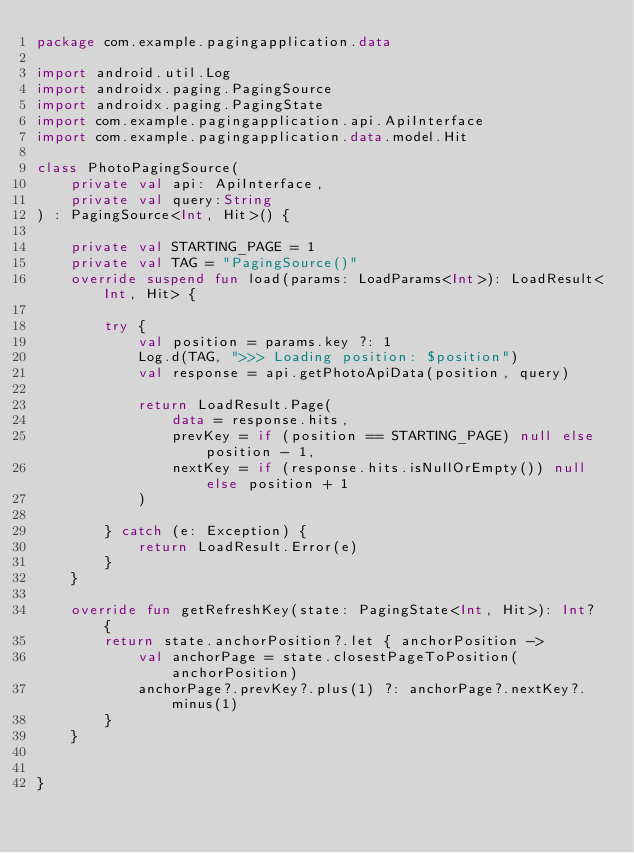Convert code to text. <code><loc_0><loc_0><loc_500><loc_500><_Kotlin_>package com.example.pagingapplication.data

import android.util.Log
import androidx.paging.PagingSource
import androidx.paging.PagingState
import com.example.pagingapplication.api.ApiInterface
import com.example.pagingapplication.data.model.Hit

class PhotoPagingSource(
    private val api: ApiInterface,
    private val query:String
) : PagingSource<Int, Hit>() {

    private val STARTING_PAGE = 1
    private val TAG = "PagingSource()"
    override suspend fun load(params: LoadParams<Int>): LoadResult<Int, Hit> {

        try {
            val position = params.key ?: 1
            Log.d(TAG, ">>> Loading position: $position")
            val response = api.getPhotoApiData(position, query)

            return LoadResult.Page(
                data = response.hits,
                prevKey = if (position == STARTING_PAGE) null else position - 1,
                nextKey = if (response.hits.isNullOrEmpty()) null else position + 1
            )

        } catch (e: Exception) {
            return LoadResult.Error(e)
        }
    }

    override fun getRefreshKey(state: PagingState<Int, Hit>): Int? {
        return state.anchorPosition?.let { anchorPosition ->
            val anchorPage = state.closestPageToPosition(anchorPosition)
            anchorPage?.prevKey?.plus(1) ?: anchorPage?.nextKey?.minus(1)
        }
    }


}</code> 